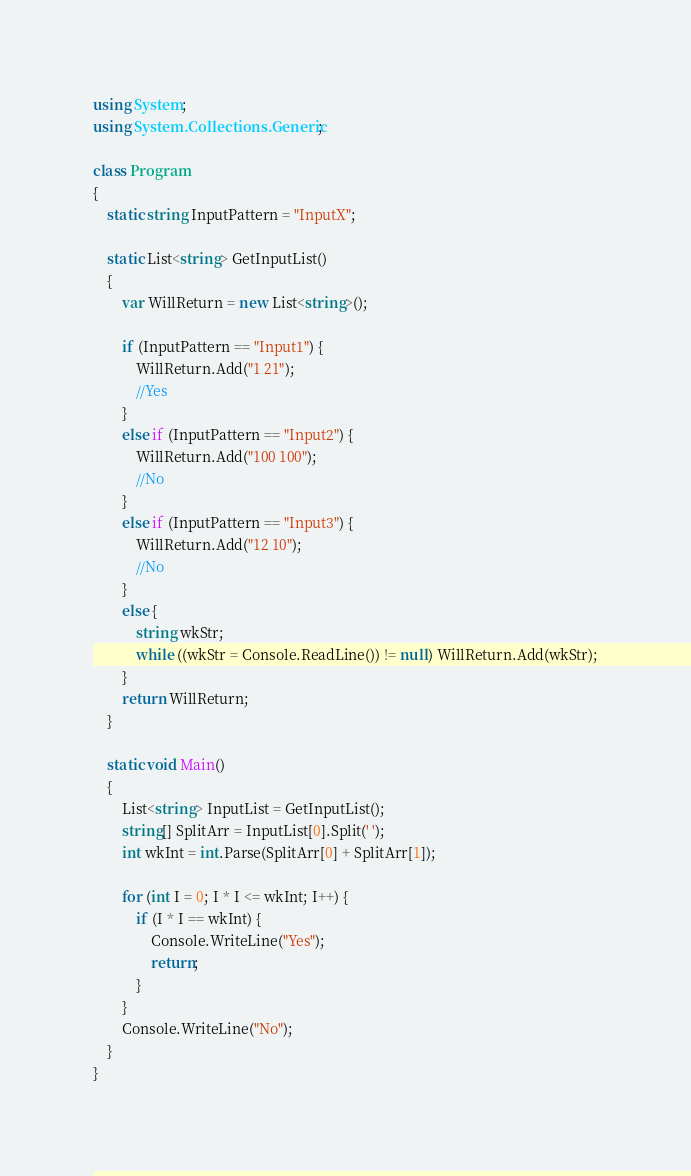Convert code to text. <code><loc_0><loc_0><loc_500><loc_500><_C#_>using System;
using System.Collections.Generic;

class Program
{
    static string InputPattern = "InputX";

    static List<string> GetInputList()
    {
        var WillReturn = new List<string>();

        if (InputPattern == "Input1") {
            WillReturn.Add("1 21");
            //Yes
        }
        else if (InputPattern == "Input2") {
            WillReturn.Add("100 100");
            //No
        }
        else if (InputPattern == "Input3") {
            WillReturn.Add("12 10");
            //No
        }
        else {
            string wkStr;
            while ((wkStr = Console.ReadLine()) != null) WillReturn.Add(wkStr);
        }
        return WillReturn;
    }

    static void Main()
    {
        List<string> InputList = GetInputList();
        string[] SplitArr = InputList[0].Split(' ');
        int wkInt = int.Parse(SplitArr[0] + SplitArr[1]);

        for (int I = 0; I * I <= wkInt; I++) {
            if (I * I == wkInt) {
                Console.WriteLine("Yes");
                return;
            }
        }
        Console.WriteLine("No");
    }
}
</code> 